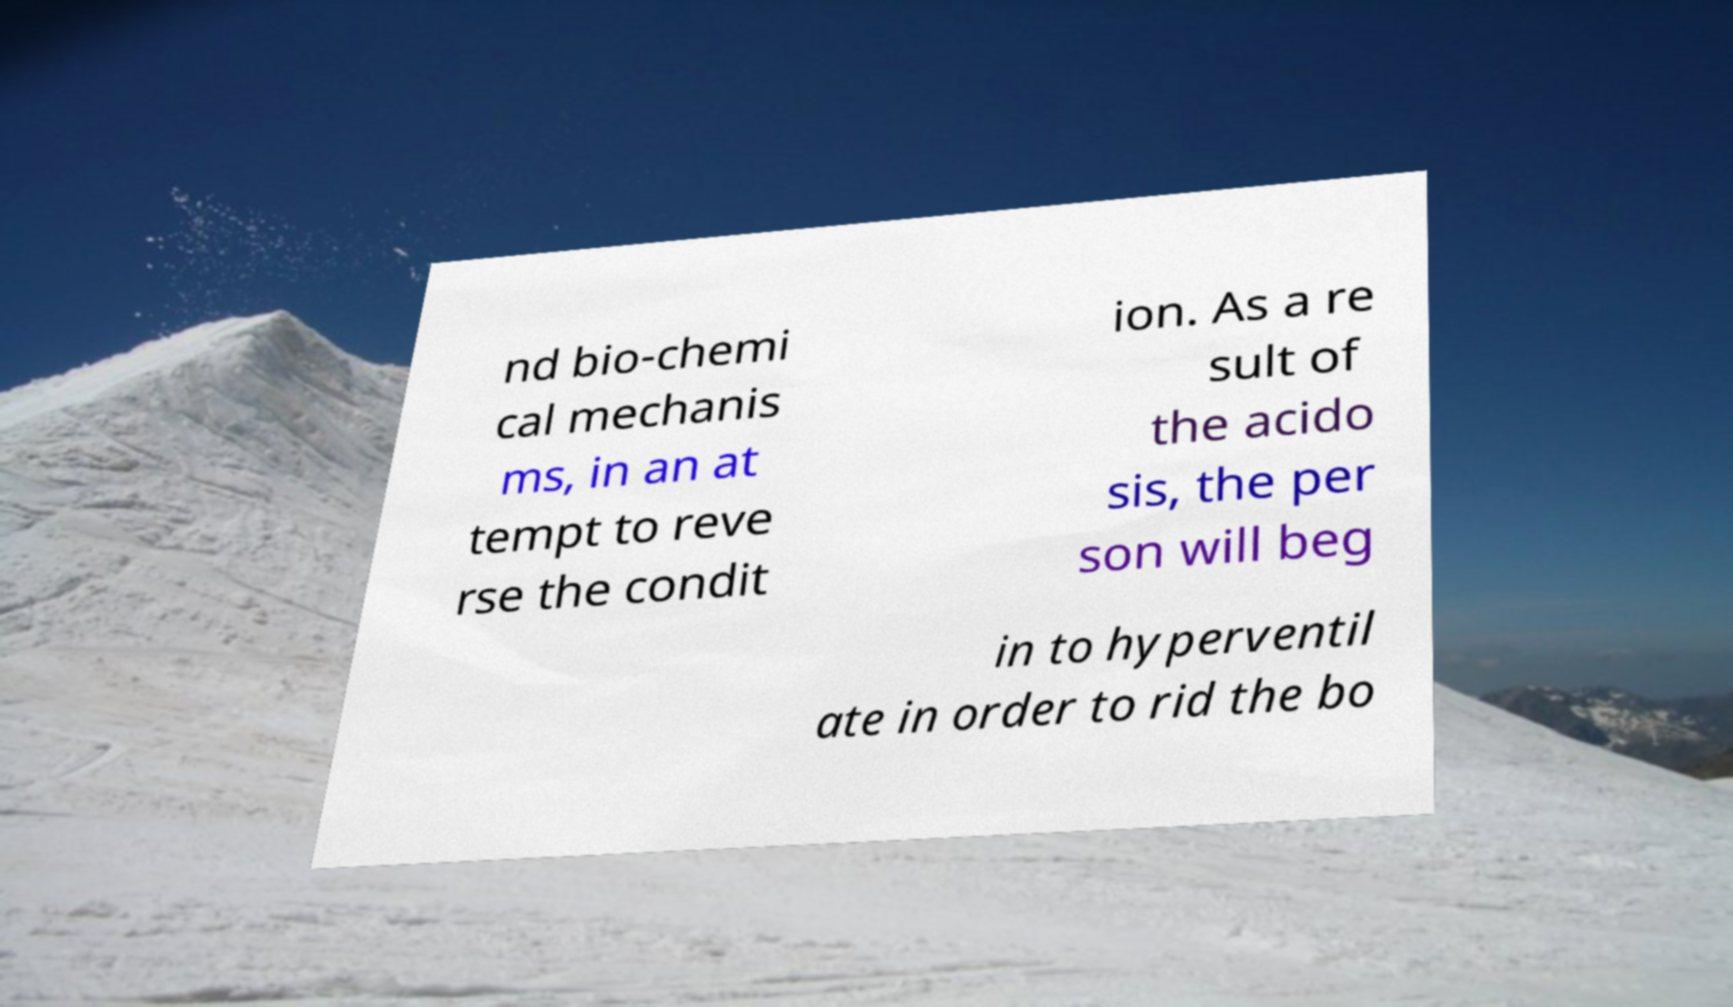Can you accurately transcribe the text from the provided image for me? nd bio-chemi cal mechanis ms, in an at tempt to reve rse the condit ion. As a re sult of the acido sis, the per son will beg in to hyperventil ate in order to rid the bo 